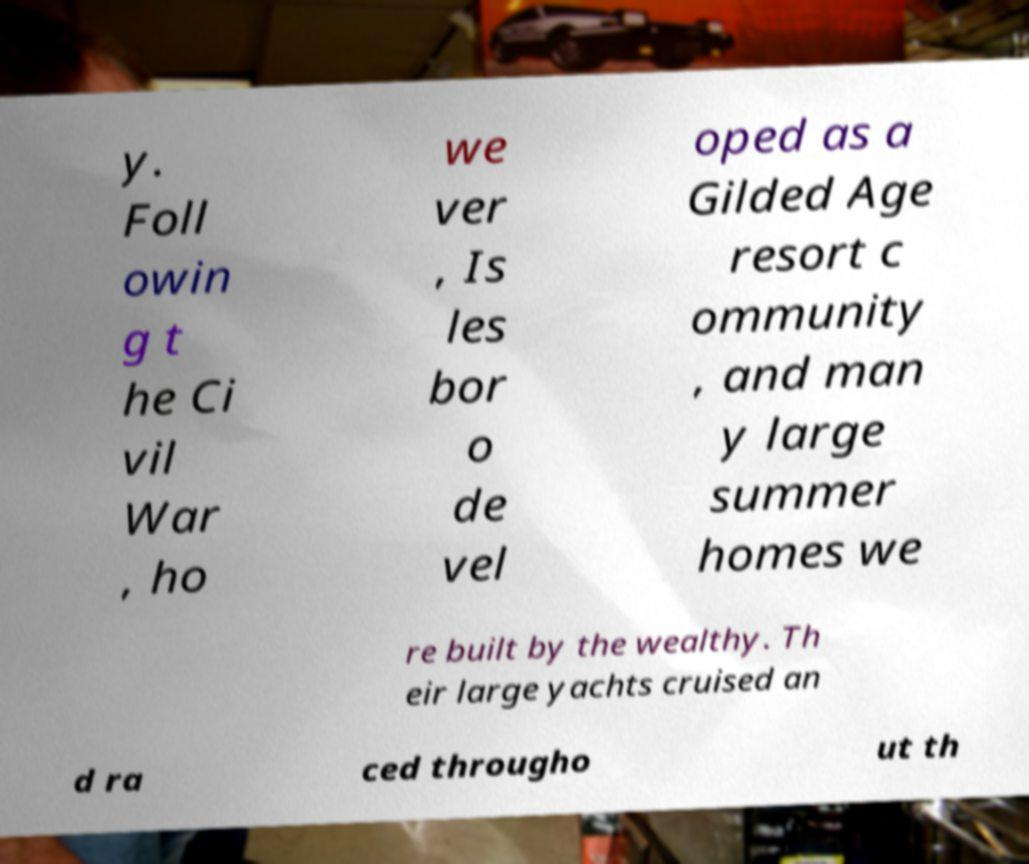Please read and relay the text visible in this image. What does it say? y. Foll owin g t he Ci vil War , ho we ver , Is les bor o de vel oped as a Gilded Age resort c ommunity , and man y large summer homes we re built by the wealthy. Th eir large yachts cruised an d ra ced througho ut th 